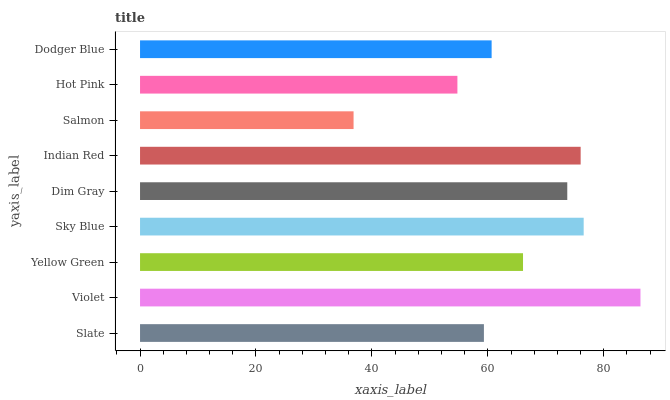Is Salmon the minimum?
Answer yes or no. Yes. Is Violet the maximum?
Answer yes or no. Yes. Is Yellow Green the minimum?
Answer yes or no. No. Is Yellow Green the maximum?
Answer yes or no. No. Is Violet greater than Yellow Green?
Answer yes or no. Yes. Is Yellow Green less than Violet?
Answer yes or no. Yes. Is Yellow Green greater than Violet?
Answer yes or no. No. Is Violet less than Yellow Green?
Answer yes or no. No. Is Yellow Green the high median?
Answer yes or no. Yes. Is Yellow Green the low median?
Answer yes or no. Yes. Is Hot Pink the high median?
Answer yes or no. No. Is Sky Blue the low median?
Answer yes or no. No. 